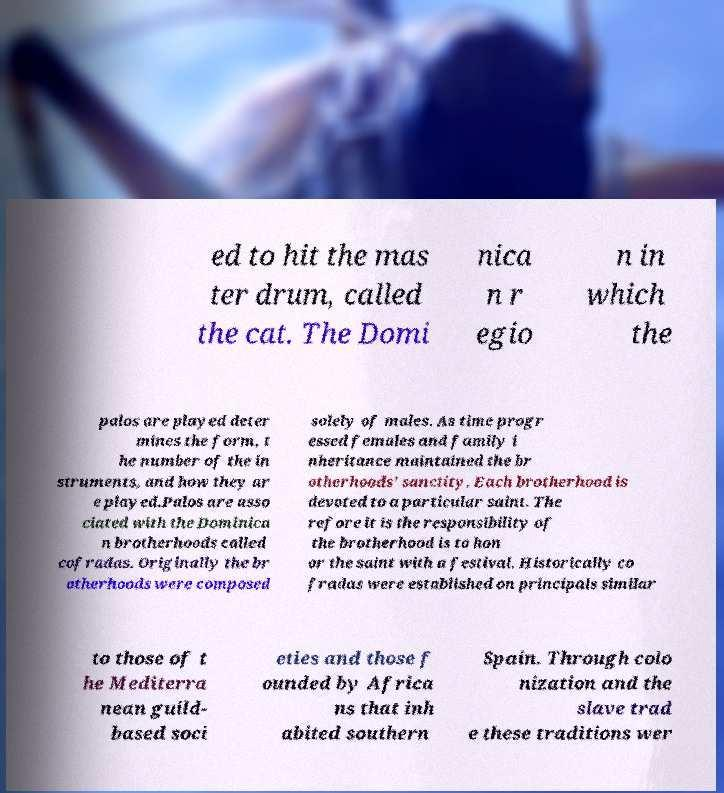Could you assist in decoding the text presented in this image and type it out clearly? ed to hit the mas ter drum, called the cat. The Domi nica n r egio n in which the palos are played deter mines the form, t he number of the in struments, and how they ar e played.Palos are asso ciated with the Dominica n brotherhoods called cofradas. Originally the br otherhoods were composed solely of males. As time progr essed females and family i nheritance maintained the br otherhoods’ sanctity. Each brotherhood is devoted to a particular saint. The refore it is the responsibility of the brotherhood is to hon or the saint with a festival. Historically co fradas were established on principals similar to those of t he Mediterra nean guild- based soci eties and those f ounded by Africa ns that inh abited southern Spain. Through colo nization and the slave trad e these traditions wer 